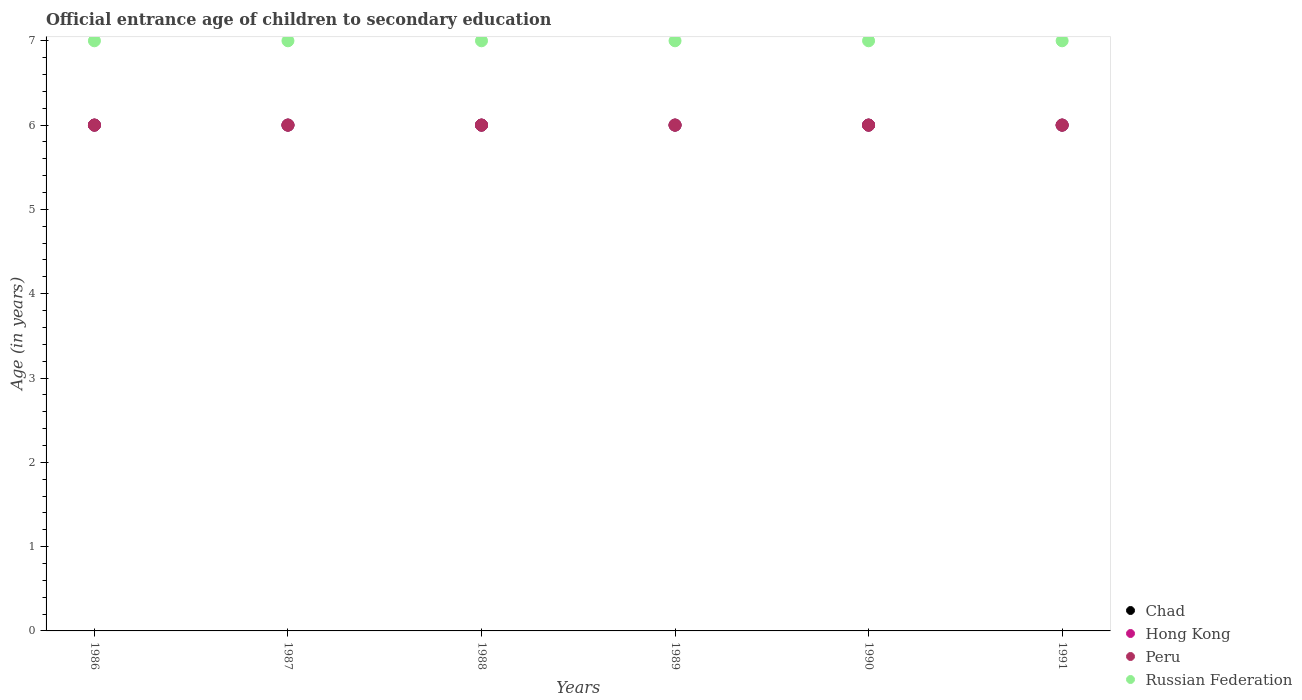What is the secondary school starting age of children in Hong Kong in 1991?
Your answer should be compact. 6. Across all years, what is the maximum secondary school starting age of children in Hong Kong?
Provide a short and direct response. 6. Across all years, what is the minimum secondary school starting age of children in Russian Federation?
Your response must be concise. 7. In which year was the secondary school starting age of children in Russian Federation maximum?
Give a very brief answer. 1986. What is the total secondary school starting age of children in Russian Federation in the graph?
Make the answer very short. 42. What is the difference between the secondary school starting age of children in Chad in 1986 and that in 1989?
Keep it short and to the point. 0. What is the difference between the secondary school starting age of children in Peru in 1986 and the secondary school starting age of children in Chad in 1987?
Provide a short and direct response. 0. In the year 1990, what is the difference between the secondary school starting age of children in Hong Kong and secondary school starting age of children in Russian Federation?
Your response must be concise. -1. Is the secondary school starting age of children in Hong Kong in 1986 less than that in 1989?
Your answer should be very brief. No. What is the difference between the highest and the second highest secondary school starting age of children in Hong Kong?
Keep it short and to the point. 0. Is the sum of the secondary school starting age of children in Hong Kong in 1986 and 1987 greater than the maximum secondary school starting age of children in Chad across all years?
Provide a succinct answer. Yes. Is it the case that in every year, the sum of the secondary school starting age of children in Russian Federation and secondary school starting age of children in Hong Kong  is greater than the secondary school starting age of children in Chad?
Give a very brief answer. Yes. Is the secondary school starting age of children in Chad strictly greater than the secondary school starting age of children in Russian Federation over the years?
Give a very brief answer. No. How many years are there in the graph?
Offer a terse response. 6. What is the difference between two consecutive major ticks on the Y-axis?
Provide a succinct answer. 1. Are the values on the major ticks of Y-axis written in scientific E-notation?
Your answer should be very brief. No. How many legend labels are there?
Provide a succinct answer. 4. What is the title of the graph?
Offer a very short reply. Official entrance age of children to secondary education. Does "Sao Tome and Principe" appear as one of the legend labels in the graph?
Offer a terse response. No. What is the label or title of the Y-axis?
Make the answer very short. Age (in years). What is the Age (in years) in Chad in 1986?
Give a very brief answer. 6. What is the Age (in years) in Hong Kong in 1986?
Ensure brevity in your answer.  6. What is the Age (in years) of Chad in 1987?
Offer a very short reply. 6. What is the Age (in years) of Hong Kong in 1987?
Offer a very short reply. 6. What is the Age (in years) in Peru in 1987?
Make the answer very short. 6. What is the Age (in years) in Chad in 1988?
Offer a very short reply. 6. What is the Age (in years) of Russian Federation in 1988?
Make the answer very short. 7. What is the Age (in years) in Hong Kong in 1989?
Offer a very short reply. 6. What is the Age (in years) of Chad in 1990?
Provide a short and direct response. 6. What is the Age (in years) in Peru in 1990?
Offer a terse response. 6. What is the Age (in years) in Chad in 1991?
Ensure brevity in your answer.  6. What is the Age (in years) of Peru in 1991?
Make the answer very short. 6. Across all years, what is the maximum Age (in years) in Peru?
Provide a short and direct response. 6. Across all years, what is the maximum Age (in years) of Russian Federation?
Give a very brief answer. 7. Across all years, what is the minimum Age (in years) of Russian Federation?
Ensure brevity in your answer.  7. What is the total Age (in years) of Hong Kong in the graph?
Give a very brief answer. 36. What is the total Age (in years) in Peru in the graph?
Provide a short and direct response. 36. What is the difference between the Age (in years) of Chad in 1986 and that in 1987?
Offer a terse response. 0. What is the difference between the Age (in years) in Hong Kong in 1986 and that in 1987?
Offer a terse response. 0. What is the difference between the Age (in years) of Russian Federation in 1986 and that in 1987?
Ensure brevity in your answer.  0. What is the difference between the Age (in years) in Chad in 1986 and that in 1988?
Provide a short and direct response. 0. What is the difference between the Age (in years) of Hong Kong in 1986 and that in 1988?
Your answer should be very brief. 0. What is the difference between the Age (in years) of Peru in 1986 and that in 1988?
Offer a very short reply. 0. What is the difference between the Age (in years) of Russian Federation in 1986 and that in 1988?
Ensure brevity in your answer.  0. What is the difference between the Age (in years) of Chad in 1986 and that in 1989?
Keep it short and to the point. 0. What is the difference between the Age (in years) of Hong Kong in 1986 and that in 1989?
Offer a terse response. 0. What is the difference between the Age (in years) in Chad in 1986 and that in 1990?
Make the answer very short. 0. What is the difference between the Age (in years) of Hong Kong in 1986 and that in 1990?
Offer a terse response. 0. What is the difference between the Age (in years) in Russian Federation in 1986 and that in 1990?
Offer a terse response. 0. What is the difference between the Age (in years) in Hong Kong in 1986 and that in 1991?
Offer a terse response. 0. What is the difference between the Age (in years) in Peru in 1986 and that in 1991?
Your response must be concise. 0. What is the difference between the Age (in years) in Russian Federation in 1986 and that in 1991?
Provide a short and direct response. 0. What is the difference between the Age (in years) in Hong Kong in 1987 and that in 1988?
Offer a terse response. 0. What is the difference between the Age (in years) in Peru in 1987 and that in 1988?
Your answer should be very brief. 0. What is the difference between the Age (in years) of Russian Federation in 1987 and that in 1988?
Your answer should be very brief. 0. What is the difference between the Age (in years) in Chad in 1987 and that in 1989?
Make the answer very short. 0. What is the difference between the Age (in years) in Hong Kong in 1987 and that in 1989?
Provide a succinct answer. 0. What is the difference between the Age (in years) of Russian Federation in 1987 and that in 1989?
Make the answer very short. 0. What is the difference between the Age (in years) of Peru in 1987 and that in 1990?
Ensure brevity in your answer.  0. What is the difference between the Age (in years) of Russian Federation in 1987 and that in 1990?
Your answer should be compact. 0. What is the difference between the Age (in years) of Chad in 1987 and that in 1991?
Your answer should be very brief. 0. What is the difference between the Age (in years) in Russian Federation in 1987 and that in 1991?
Keep it short and to the point. 0. What is the difference between the Age (in years) in Chad in 1988 and that in 1989?
Your answer should be compact. 0. What is the difference between the Age (in years) of Hong Kong in 1988 and that in 1989?
Keep it short and to the point. 0. What is the difference between the Age (in years) in Peru in 1988 and that in 1989?
Your response must be concise. 0. What is the difference between the Age (in years) in Russian Federation in 1988 and that in 1989?
Provide a short and direct response. 0. What is the difference between the Age (in years) in Chad in 1988 and that in 1991?
Provide a succinct answer. 0. What is the difference between the Age (in years) in Russian Federation in 1988 and that in 1991?
Keep it short and to the point. 0. What is the difference between the Age (in years) in Chad in 1989 and that in 1990?
Offer a very short reply. 0. What is the difference between the Age (in years) in Chad in 1989 and that in 1991?
Offer a terse response. 0. What is the difference between the Age (in years) in Peru in 1989 and that in 1991?
Make the answer very short. 0. What is the difference between the Age (in years) in Russian Federation in 1989 and that in 1991?
Your answer should be compact. 0. What is the difference between the Age (in years) in Hong Kong in 1990 and that in 1991?
Your answer should be compact. 0. What is the difference between the Age (in years) in Chad in 1986 and the Age (in years) in Peru in 1987?
Offer a terse response. 0. What is the difference between the Age (in years) in Chad in 1986 and the Age (in years) in Russian Federation in 1987?
Provide a short and direct response. -1. What is the difference between the Age (in years) in Hong Kong in 1986 and the Age (in years) in Peru in 1987?
Ensure brevity in your answer.  0. What is the difference between the Age (in years) in Hong Kong in 1986 and the Age (in years) in Russian Federation in 1987?
Give a very brief answer. -1. What is the difference between the Age (in years) of Peru in 1986 and the Age (in years) of Russian Federation in 1987?
Make the answer very short. -1. What is the difference between the Age (in years) of Chad in 1986 and the Age (in years) of Hong Kong in 1988?
Your response must be concise. 0. What is the difference between the Age (in years) of Chad in 1986 and the Age (in years) of Peru in 1988?
Your response must be concise. 0. What is the difference between the Age (in years) of Peru in 1986 and the Age (in years) of Russian Federation in 1988?
Offer a very short reply. -1. What is the difference between the Age (in years) of Chad in 1986 and the Age (in years) of Hong Kong in 1989?
Your answer should be very brief. 0. What is the difference between the Age (in years) of Chad in 1986 and the Age (in years) of Russian Federation in 1989?
Keep it short and to the point. -1. What is the difference between the Age (in years) of Hong Kong in 1986 and the Age (in years) of Peru in 1989?
Keep it short and to the point. 0. What is the difference between the Age (in years) of Hong Kong in 1986 and the Age (in years) of Russian Federation in 1989?
Provide a succinct answer. -1. What is the difference between the Age (in years) in Chad in 1986 and the Age (in years) in Hong Kong in 1990?
Your response must be concise. 0. What is the difference between the Age (in years) in Hong Kong in 1986 and the Age (in years) in Peru in 1991?
Provide a succinct answer. 0. What is the difference between the Age (in years) of Peru in 1986 and the Age (in years) of Russian Federation in 1991?
Make the answer very short. -1. What is the difference between the Age (in years) of Hong Kong in 1987 and the Age (in years) of Peru in 1988?
Your answer should be very brief. 0. What is the difference between the Age (in years) of Hong Kong in 1987 and the Age (in years) of Russian Federation in 1988?
Make the answer very short. -1. What is the difference between the Age (in years) in Peru in 1987 and the Age (in years) in Russian Federation in 1988?
Provide a short and direct response. -1. What is the difference between the Age (in years) of Chad in 1987 and the Age (in years) of Hong Kong in 1989?
Keep it short and to the point. 0. What is the difference between the Age (in years) in Chad in 1987 and the Age (in years) in Peru in 1989?
Ensure brevity in your answer.  0. What is the difference between the Age (in years) in Chad in 1987 and the Age (in years) in Russian Federation in 1989?
Make the answer very short. -1. What is the difference between the Age (in years) in Hong Kong in 1987 and the Age (in years) in Peru in 1990?
Make the answer very short. 0. What is the difference between the Age (in years) in Hong Kong in 1987 and the Age (in years) in Russian Federation in 1990?
Provide a short and direct response. -1. What is the difference between the Age (in years) of Peru in 1987 and the Age (in years) of Russian Federation in 1990?
Offer a terse response. -1. What is the difference between the Age (in years) of Chad in 1987 and the Age (in years) of Hong Kong in 1991?
Give a very brief answer. 0. What is the difference between the Age (in years) of Chad in 1987 and the Age (in years) of Peru in 1991?
Give a very brief answer. 0. What is the difference between the Age (in years) of Chad in 1988 and the Age (in years) of Peru in 1989?
Provide a short and direct response. 0. What is the difference between the Age (in years) in Chad in 1988 and the Age (in years) in Russian Federation in 1989?
Offer a terse response. -1. What is the difference between the Age (in years) in Hong Kong in 1988 and the Age (in years) in Peru in 1989?
Your answer should be very brief. 0. What is the difference between the Age (in years) of Chad in 1988 and the Age (in years) of Hong Kong in 1990?
Keep it short and to the point. 0. What is the difference between the Age (in years) in Chad in 1988 and the Age (in years) in Peru in 1990?
Your answer should be very brief. 0. What is the difference between the Age (in years) in Hong Kong in 1988 and the Age (in years) in Peru in 1990?
Give a very brief answer. 0. What is the difference between the Age (in years) of Chad in 1988 and the Age (in years) of Hong Kong in 1991?
Provide a succinct answer. 0. What is the difference between the Age (in years) in Chad in 1988 and the Age (in years) in Peru in 1991?
Your answer should be compact. 0. What is the difference between the Age (in years) in Hong Kong in 1988 and the Age (in years) in Russian Federation in 1991?
Give a very brief answer. -1. What is the difference between the Age (in years) in Peru in 1988 and the Age (in years) in Russian Federation in 1991?
Offer a terse response. -1. What is the difference between the Age (in years) in Chad in 1989 and the Age (in years) in Hong Kong in 1990?
Provide a succinct answer. 0. What is the difference between the Age (in years) of Chad in 1989 and the Age (in years) of Peru in 1990?
Offer a very short reply. 0. What is the difference between the Age (in years) of Chad in 1989 and the Age (in years) of Russian Federation in 1990?
Give a very brief answer. -1. What is the difference between the Age (in years) in Chad in 1989 and the Age (in years) in Peru in 1991?
Your answer should be compact. 0. What is the difference between the Age (in years) of Chad in 1989 and the Age (in years) of Russian Federation in 1991?
Your response must be concise. -1. What is the difference between the Age (in years) of Chad in 1990 and the Age (in years) of Hong Kong in 1991?
Provide a succinct answer. 0. What is the difference between the Age (in years) of Chad in 1990 and the Age (in years) of Russian Federation in 1991?
Keep it short and to the point. -1. What is the difference between the Age (in years) in Hong Kong in 1990 and the Age (in years) in Peru in 1991?
Provide a succinct answer. 0. What is the average Age (in years) of Chad per year?
Provide a succinct answer. 6. What is the average Age (in years) of Peru per year?
Give a very brief answer. 6. What is the average Age (in years) of Russian Federation per year?
Keep it short and to the point. 7. In the year 1986, what is the difference between the Age (in years) in Hong Kong and Age (in years) in Peru?
Give a very brief answer. 0. In the year 1987, what is the difference between the Age (in years) in Chad and Age (in years) in Hong Kong?
Provide a succinct answer. 0. In the year 1987, what is the difference between the Age (in years) of Chad and Age (in years) of Russian Federation?
Your answer should be compact. -1. In the year 1987, what is the difference between the Age (in years) in Hong Kong and Age (in years) in Peru?
Offer a terse response. 0. In the year 1987, what is the difference between the Age (in years) of Peru and Age (in years) of Russian Federation?
Your answer should be compact. -1. In the year 1988, what is the difference between the Age (in years) of Chad and Age (in years) of Hong Kong?
Keep it short and to the point. 0. In the year 1988, what is the difference between the Age (in years) in Chad and Age (in years) in Russian Federation?
Ensure brevity in your answer.  -1. In the year 1988, what is the difference between the Age (in years) of Hong Kong and Age (in years) of Russian Federation?
Provide a succinct answer. -1. In the year 1988, what is the difference between the Age (in years) of Peru and Age (in years) of Russian Federation?
Your answer should be compact. -1. In the year 1989, what is the difference between the Age (in years) of Chad and Age (in years) of Hong Kong?
Keep it short and to the point. 0. In the year 1989, what is the difference between the Age (in years) of Chad and Age (in years) of Peru?
Provide a succinct answer. 0. In the year 1989, what is the difference between the Age (in years) of Hong Kong and Age (in years) of Peru?
Provide a short and direct response. 0. In the year 1989, what is the difference between the Age (in years) in Hong Kong and Age (in years) in Russian Federation?
Keep it short and to the point. -1. In the year 1989, what is the difference between the Age (in years) of Peru and Age (in years) of Russian Federation?
Make the answer very short. -1. In the year 1990, what is the difference between the Age (in years) of Chad and Age (in years) of Hong Kong?
Make the answer very short. 0. In the year 1990, what is the difference between the Age (in years) in Hong Kong and Age (in years) in Peru?
Your answer should be very brief. 0. In the year 1990, what is the difference between the Age (in years) in Hong Kong and Age (in years) in Russian Federation?
Your response must be concise. -1. In the year 1990, what is the difference between the Age (in years) in Peru and Age (in years) in Russian Federation?
Make the answer very short. -1. In the year 1991, what is the difference between the Age (in years) in Chad and Age (in years) in Hong Kong?
Your response must be concise. 0. In the year 1991, what is the difference between the Age (in years) of Chad and Age (in years) of Russian Federation?
Make the answer very short. -1. In the year 1991, what is the difference between the Age (in years) of Peru and Age (in years) of Russian Federation?
Provide a succinct answer. -1. What is the ratio of the Age (in years) in Hong Kong in 1986 to that in 1989?
Offer a terse response. 1. What is the ratio of the Age (in years) in Russian Federation in 1986 to that in 1989?
Offer a terse response. 1. What is the ratio of the Age (in years) in Chad in 1986 to that in 1990?
Ensure brevity in your answer.  1. What is the ratio of the Age (in years) in Hong Kong in 1986 to that in 1990?
Offer a very short reply. 1. What is the ratio of the Age (in years) of Hong Kong in 1986 to that in 1991?
Keep it short and to the point. 1. What is the ratio of the Age (in years) in Russian Federation in 1986 to that in 1991?
Give a very brief answer. 1. What is the ratio of the Age (in years) of Chad in 1987 to that in 1988?
Your answer should be compact. 1. What is the ratio of the Age (in years) of Peru in 1987 to that in 1988?
Provide a short and direct response. 1. What is the ratio of the Age (in years) of Chad in 1987 to that in 1990?
Give a very brief answer. 1. What is the ratio of the Age (in years) of Hong Kong in 1987 to that in 1990?
Offer a terse response. 1. What is the ratio of the Age (in years) of Chad in 1987 to that in 1991?
Your answer should be compact. 1. What is the ratio of the Age (in years) in Russian Federation in 1987 to that in 1991?
Provide a short and direct response. 1. What is the ratio of the Age (in years) of Chad in 1988 to that in 1989?
Make the answer very short. 1. What is the ratio of the Age (in years) in Peru in 1988 to that in 1989?
Make the answer very short. 1. What is the ratio of the Age (in years) of Russian Federation in 1988 to that in 1989?
Give a very brief answer. 1. What is the ratio of the Age (in years) of Chad in 1988 to that in 1990?
Offer a terse response. 1. What is the ratio of the Age (in years) of Hong Kong in 1988 to that in 1990?
Provide a short and direct response. 1. What is the ratio of the Age (in years) in Peru in 1988 to that in 1990?
Make the answer very short. 1. What is the ratio of the Age (in years) in Russian Federation in 1988 to that in 1990?
Offer a very short reply. 1. What is the ratio of the Age (in years) of Chad in 1988 to that in 1991?
Provide a succinct answer. 1. What is the ratio of the Age (in years) in Hong Kong in 1988 to that in 1991?
Provide a succinct answer. 1. What is the ratio of the Age (in years) of Peru in 1988 to that in 1991?
Offer a terse response. 1. What is the ratio of the Age (in years) of Chad in 1989 to that in 1990?
Give a very brief answer. 1. What is the ratio of the Age (in years) of Hong Kong in 1989 to that in 1990?
Provide a short and direct response. 1. What is the ratio of the Age (in years) in Russian Federation in 1989 to that in 1990?
Offer a very short reply. 1. What is the ratio of the Age (in years) of Peru in 1989 to that in 1991?
Your response must be concise. 1. What is the ratio of the Age (in years) of Russian Federation in 1989 to that in 1991?
Provide a short and direct response. 1. What is the ratio of the Age (in years) of Chad in 1990 to that in 1991?
Give a very brief answer. 1. What is the ratio of the Age (in years) of Peru in 1990 to that in 1991?
Provide a short and direct response. 1. What is the difference between the highest and the second highest Age (in years) in Chad?
Your answer should be very brief. 0. What is the difference between the highest and the second highest Age (in years) of Hong Kong?
Keep it short and to the point. 0. What is the difference between the highest and the second highest Age (in years) of Russian Federation?
Give a very brief answer. 0. What is the difference between the highest and the lowest Age (in years) of Chad?
Ensure brevity in your answer.  0. What is the difference between the highest and the lowest Age (in years) in Peru?
Your response must be concise. 0. 